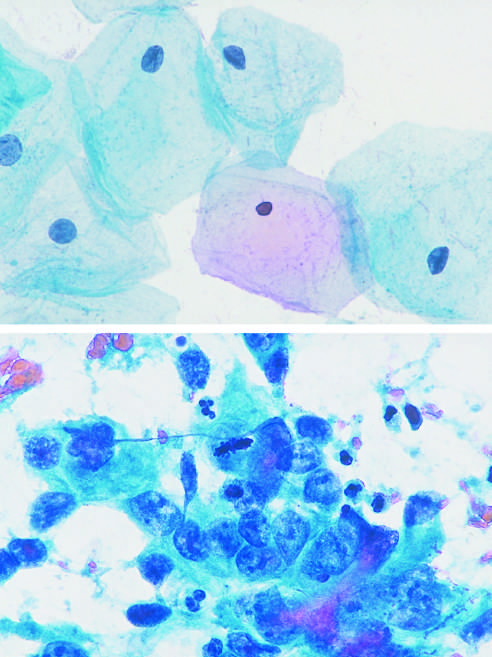re a few interspersed neutrophils, much smaller in size and with compact, lobate nuclei, seen?
Answer the question using a single word or phrase. Yes 